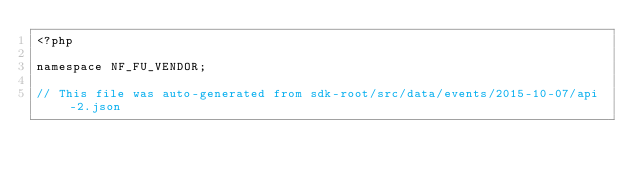<code> <loc_0><loc_0><loc_500><loc_500><_PHP_><?php

namespace NF_FU_VENDOR;

// This file was auto-generated from sdk-root/src/data/events/2015-10-07/api-2.json</code> 